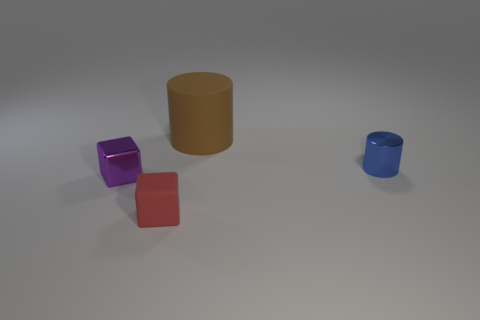The cube that is made of the same material as the large object is what color?
Make the answer very short. Red. Are there an equal number of tiny metal objects that are right of the tiny purple metal block and matte objects behind the metallic cylinder?
Keep it short and to the point. Yes. There is a matte thing that is in front of the tiny object left of the tiny red matte block; what shape is it?
Your response must be concise. Cube. There is a small object that is the same shape as the large matte object; what is its material?
Your answer should be compact. Metal. There is a shiny cylinder that is the same size as the metallic cube; what is its color?
Your response must be concise. Blue. Are there the same number of purple shiny blocks that are behind the big brown object and tiny red matte blocks?
Your answer should be compact. No. What is the color of the small metallic thing to the right of the metal thing left of the small metallic cylinder?
Your response must be concise. Blue. What size is the matte thing behind the tiny object that is in front of the small metallic cube?
Provide a succinct answer. Large. How many other things are there of the same size as the rubber cylinder?
Offer a very short reply. 0. What color is the shiny thing to the right of the rubber thing in front of the small metallic object to the right of the red matte block?
Offer a very short reply. Blue. 